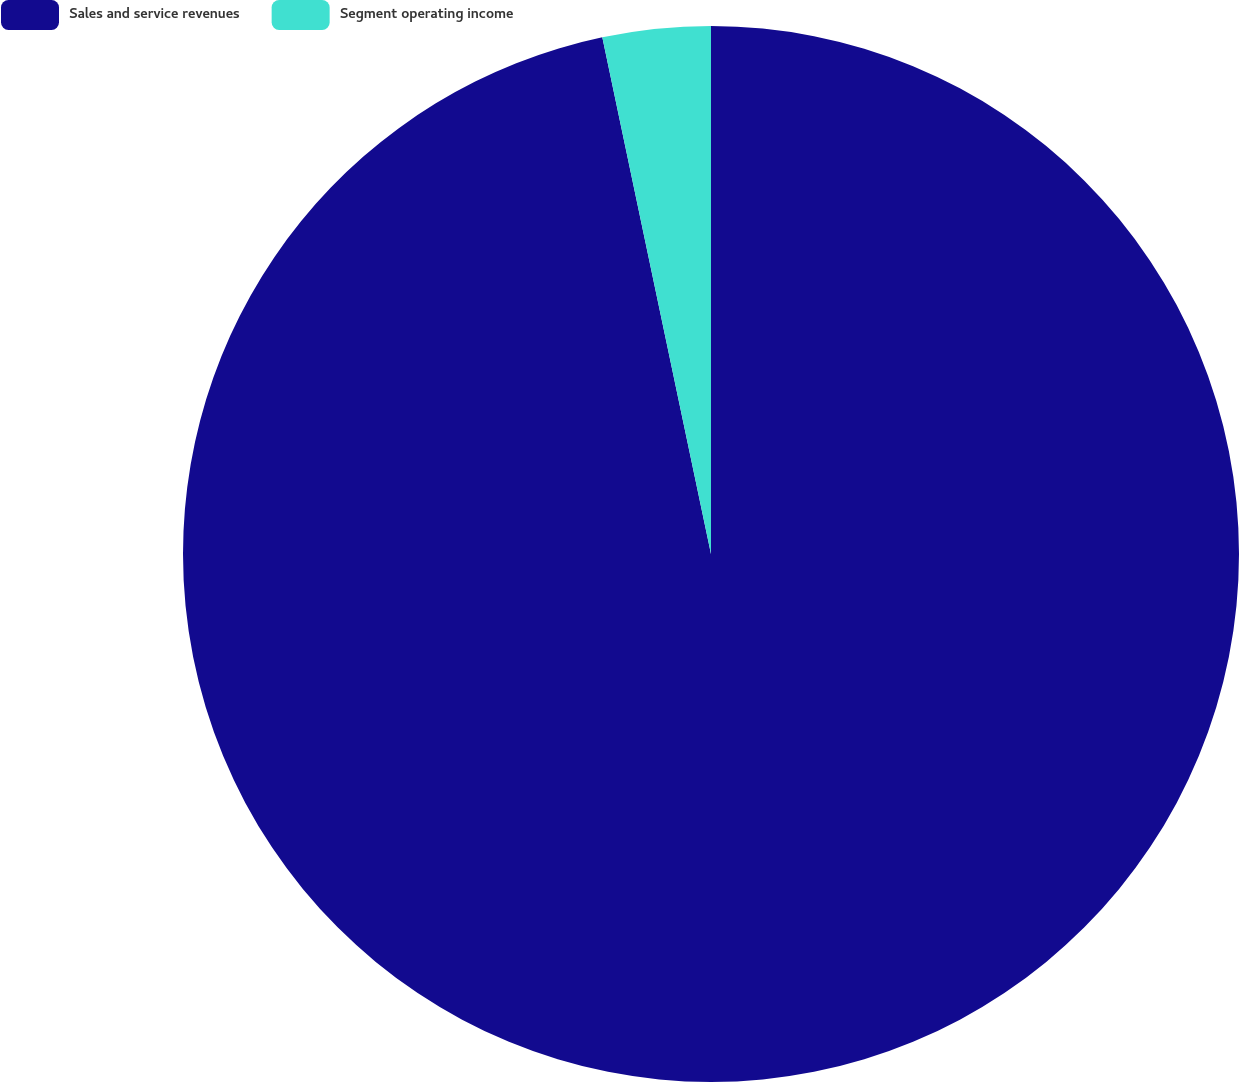<chart> <loc_0><loc_0><loc_500><loc_500><pie_chart><fcel>Sales and service revenues<fcel>Segment operating income<nl><fcel>96.7%<fcel>3.3%<nl></chart> 